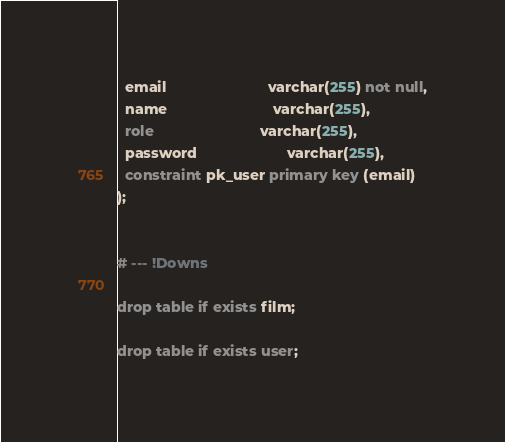Convert code to text. <code><loc_0><loc_0><loc_500><loc_500><_SQL_>  email                         varchar(255) not null,
  name                          varchar(255),
  role                          varchar(255),
  password                      varchar(255),
  constraint pk_user primary key (email)
);


# --- !Downs

drop table if exists film;

drop table if exists user;

</code> 